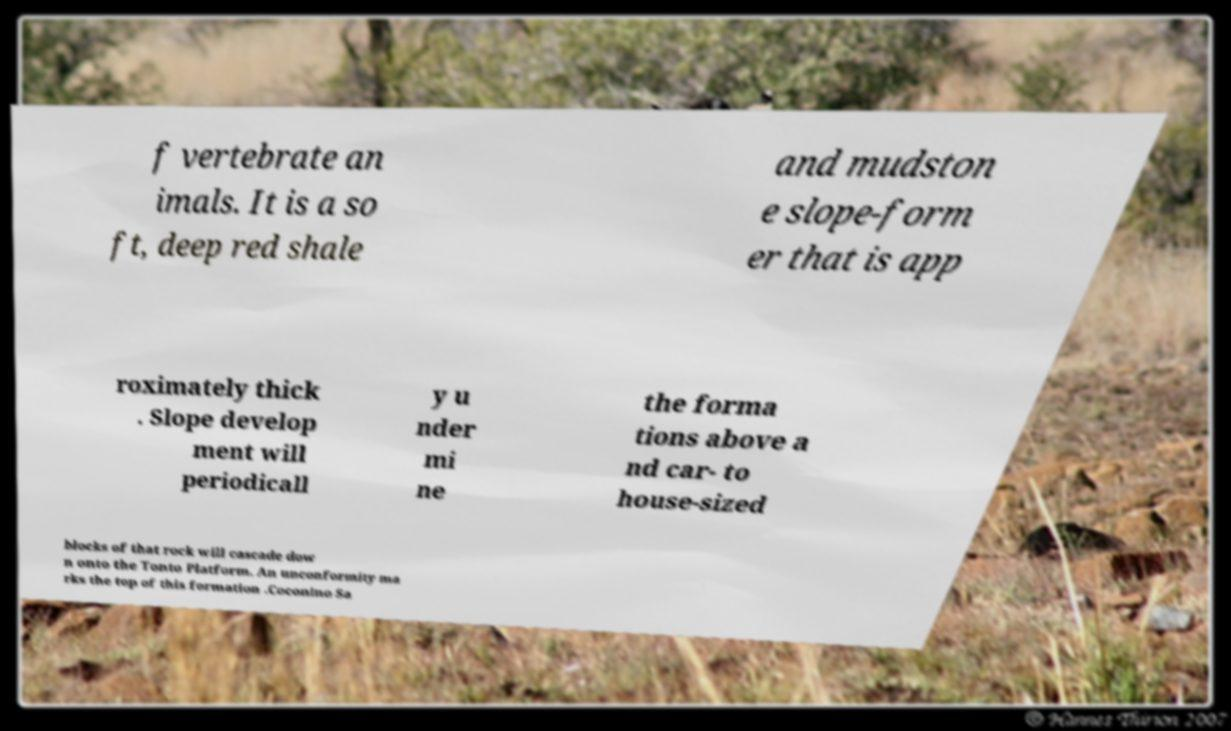Can you read and provide the text displayed in the image?This photo seems to have some interesting text. Can you extract and type it out for me? f vertebrate an imals. It is a so ft, deep red shale and mudston e slope-form er that is app roximately thick . Slope develop ment will periodicall y u nder mi ne the forma tions above a nd car- to house-sized blocks of that rock will cascade dow n onto the Tonto Platform. An unconformity ma rks the top of this formation .Coconino Sa 